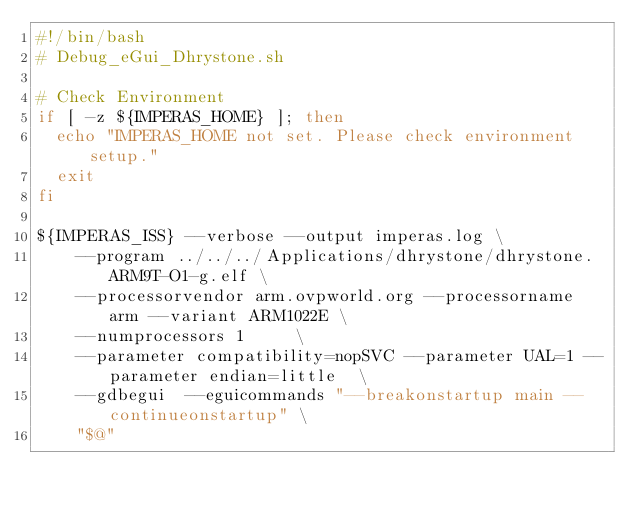<code> <loc_0><loc_0><loc_500><loc_500><_Bash_>#!/bin/bash
# Debug_eGui_Dhrystone.sh

# Check Environment
if [ -z ${IMPERAS_HOME} ]; then
  echo "IMPERAS_HOME not set. Please check environment setup."
  exit
fi

${IMPERAS_ISS} --verbose --output imperas.log \
    --program ../../../Applications/dhrystone/dhrystone.ARM9T-O1-g.elf \
    --processorvendor arm.ovpworld.org --processorname arm --variant ARM1022E \
    --numprocessors 1     \
    --parameter compatibility=nopSVC --parameter UAL=1 --parameter endian=little  \
    --gdbegui  --eguicommands "--breakonstartup main --continueonstartup" \
    "$@"


</code> 